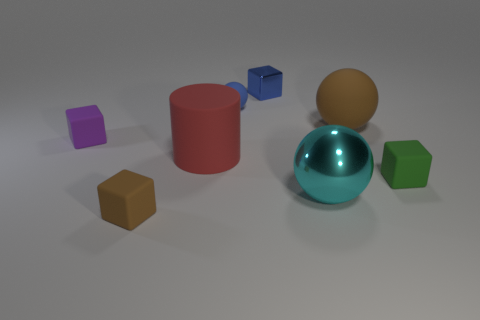Subtract all big cyan metallic balls. How many balls are left? 2 Subtract all purple cubes. How many cubes are left? 3 Subtract all cyan cubes. Subtract all red spheres. How many cubes are left? 4 Add 1 rubber cubes. How many objects exist? 9 Subtract all cylinders. How many objects are left? 7 Subtract all blue matte things. Subtract all rubber objects. How many objects are left? 1 Add 7 small green objects. How many small green objects are left? 8 Add 2 purple things. How many purple things exist? 3 Subtract 0 gray cylinders. How many objects are left? 8 